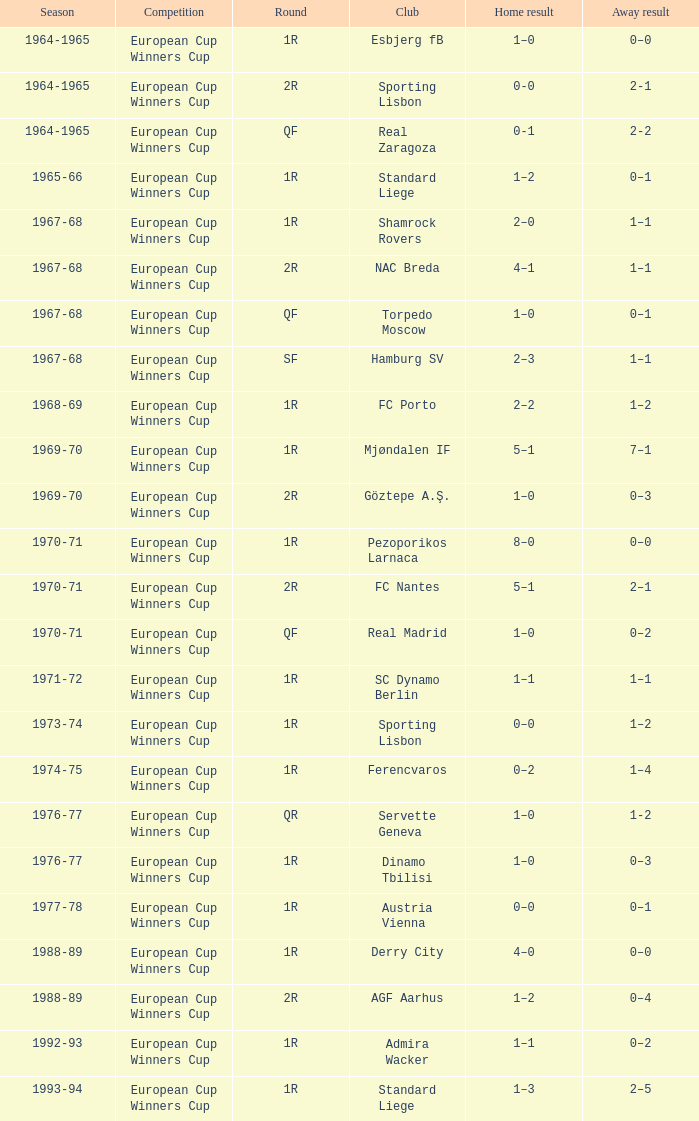What team is associated with a 1-1 away outcome, a 1r round, and the 1967-68 season? Shamrock Rovers. 